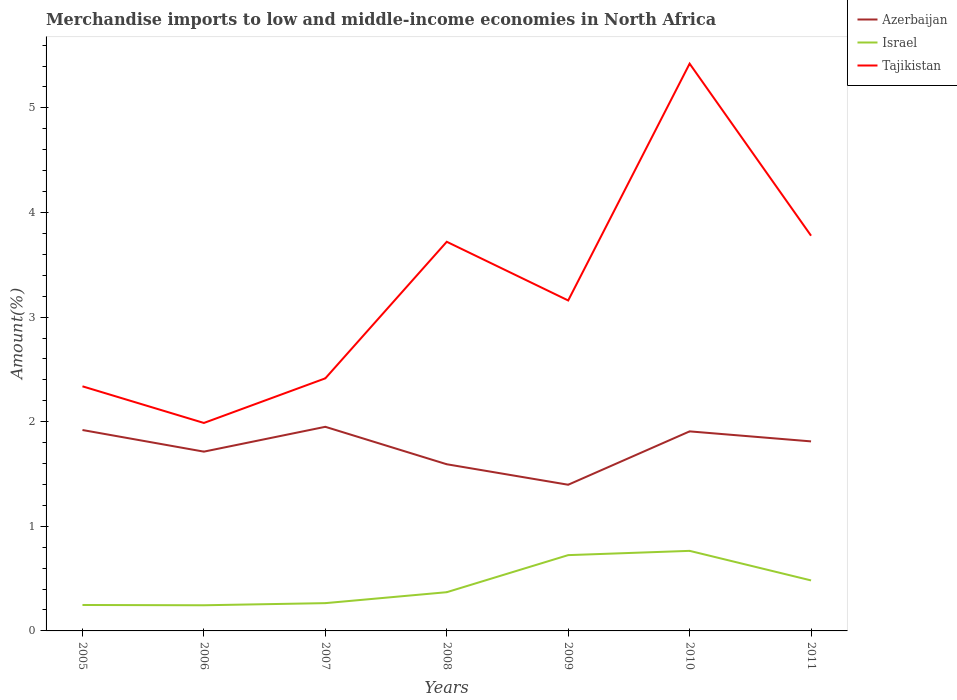Is the number of lines equal to the number of legend labels?
Your response must be concise. Yes. Across all years, what is the maximum percentage of amount earned from merchandise imports in Azerbaijan?
Your answer should be compact. 1.4. What is the total percentage of amount earned from merchandise imports in Tajikistan in the graph?
Offer a very short reply. -0.06. What is the difference between the highest and the second highest percentage of amount earned from merchandise imports in Israel?
Provide a succinct answer. 0.52. Is the percentage of amount earned from merchandise imports in Azerbaijan strictly greater than the percentage of amount earned from merchandise imports in Tajikistan over the years?
Your response must be concise. Yes. How many lines are there?
Give a very brief answer. 3. How are the legend labels stacked?
Keep it short and to the point. Vertical. What is the title of the graph?
Provide a succinct answer. Merchandise imports to low and middle-income economies in North Africa. What is the label or title of the X-axis?
Offer a very short reply. Years. What is the label or title of the Y-axis?
Ensure brevity in your answer.  Amount(%). What is the Amount(%) of Azerbaijan in 2005?
Your answer should be compact. 1.92. What is the Amount(%) of Israel in 2005?
Your response must be concise. 0.25. What is the Amount(%) in Tajikistan in 2005?
Ensure brevity in your answer.  2.34. What is the Amount(%) of Azerbaijan in 2006?
Keep it short and to the point. 1.71. What is the Amount(%) of Israel in 2006?
Provide a short and direct response. 0.25. What is the Amount(%) of Tajikistan in 2006?
Offer a very short reply. 1.99. What is the Amount(%) of Azerbaijan in 2007?
Your answer should be compact. 1.95. What is the Amount(%) in Israel in 2007?
Your answer should be compact. 0.27. What is the Amount(%) in Tajikistan in 2007?
Your answer should be very brief. 2.41. What is the Amount(%) of Azerbaijan in 2008?
Offer a terse response. 1.59. What is the Amount(%) of Israel in 2008?
Offer a very short reply. 0.37. What is the Amount(%) in Tajikistan in 2008?
Your response must be concise. 3.72. What is the Amount(%) in Azerbaijan in 2009?
Offer a very short reply. 1.4. What is the Amount(%) of Israel in 2009?
Provide a succinct answer. 0.72. What is the Amount(%) of Tajikistan in 2009?
Provide a short and direct response. 3.16. What is the Amount(%) of Azerbaijan in 2010?
Offer a very short reply. 1.91. What is the Amount(%) in Israel in 2010?
Your answer should be very brief. 0.77. What is the Amount(%) of Tajikistan in 2010?
Provide a short and direct response. 5.42. What is the Amount(%) in Azerbaijan in 2011?
Your answer should be compact. 1.81. What is the Amount(%) of Israel in 2011?
Your response must be concise. 0.48. What is the Amount(%) of Tajikistan in 2011?
Keep it short and to the point. 3.78. Across all years, what is the maximum Amount(%) in Azerbaijan?
Make the answer very short. 1.95. Across all years, what is the maximum Amount(%) of Israel?
Provide a succinct answer. 0.77. Across all years, what is the maximum Amount(%) of Tajikistan?
Your answer should be compact. 5.42. Across all years, what is the minimum Amount(%) of Azerbaijan?
Offer a terse response. 1.4. Across all years, what is the minimum Amount(%) of Israel?
Your answer should be compact. 0.25. Across all years, what is the minimum Amount(%) in Tajikistan?
Keep it short and to the point. 1.99. What is the total Amount(%) in Azerbaijan in the graph?
Offer a very short reply. 12.3. What is the total Amount(%) in Israel in the graph?
Your answer should be very brief. 3.1. What is the total Amount(%) of Tajikistan in the graph?
Make the answer very short. 22.82. What is the difference between the Amount(%) in Azerbaijan in 2005 and that in 2006?
Your answer should be very brief. 0.21. What is the difference between the Amount(%) in Israel in 2005 and that in 2006?
Ensure brevity in your answer.  0. What is the difference between the Amount(%) in Tajikistan in 2005 and that in 2006?
Make the answer very short. 0.35. What is the difference between the Amount(%) in Azerbaijan in 2005 and that in 2007?
Provide a succinct answer. -0.03. What is the difference between the Amount(%) of Israel in 2005 and that in 2007?
Ensure brevity in your answer.  -0.02. What is the difference between the Amount(%) of Tajikistan in 2005 and that in 2007?
Make the answer very short. -0.08. What is the difference between the Amount(%) in Azerbaijan in 2005 and that in 2008?
Keep it short and to the point. 0.33. What is the difference between the Amount(%) of Israel in 2005 and that in 2008?
Give a very brief answer. -0.12. What is the difference between the Amount(%) of Tajikistan in 2005 and that in 2008?
Offer a terse response. -1.38. What is the difference between the Amount(%) in Azerbaijan in 2005 and that in 2009?
Ensure brevity in your answer.  0.52. What is the difference between the Amount(%) of Israel in 2005 and that in 2009?
Make the answer very short. -0.48. What is the difference between the Amount(%) of Tajikistan in 2005 and that in 2009?
Provide a succinct answer. -0.82. What is the difference between the Amount(%) in Azerbaijan in 2005 and that in 2010?
Your response must be concise. 0.01. What is the difference between the Amount(%) in Israel in 2005 and that in 2010?
Your answer should be compact. -0.52. What is the difference between the Amount(%) in Tajikistan in 2005 and that in 2010?
Your response must be concise. -3.08. What is the difference between the Amount(%) of Azerbaijan in 2005 and that in 2011?
Provide a succinct answer. 0.11. What is the difference between the Amount(%) in Israel in 2005 and that in 2011?
Give a very brief answer. -0.23. What is the difference between the Amount(%) of Tajikistan in 2005 and that in 2011?
Offer a very short reply. -1.44. What is the difference between the Amount(%) of Azerbaijan in 2006 and that in 2007?
Ensure brevity in your answer.  -0.24. What is the difference between the Amount(%) of Israel in 2006 and that in 2007?
Make the answer very short. -0.02. What is the difference between the Amount(%) of Tajikistan in 2006 and that in 2007?
Offer a terse response. -0.43. What is the difference between the Amount(%) of Azerbaijan in 2006 and that in 2008?
Offer a very short reply. 0.12. What is the difference between the Amount(%) of Israel in 2006 and that in 2008?
Keep it short and to the point. -0.12. What is the difference between the Amount(%) in Tajikistan in 2006 and that in 2008?
Your response must be concise. -1.73. What is the difference between the Amount(%) of Azerbaijan in 2006 and that in 2009?
Provide a short and direct response. 0.32. What is the difference between the Amount(%) in Israel in 2006 and that in 2009?
Offer a very short reply. -0.48. What is the difference between the Amount(%) of Tajikistan in 2006 and that in 2009?
Offer a very short reply. -1.17. What is the difference between the Amount(%) of Azerbaijan in 2006 and that in 2010?
Your answer should be very brief. -0.19. What is the difference between the Amount(%) in Israel in 2006 and that in 2010?
Your answer should be compact. -0.52. What is the difference between the Amount(%) of Tajikistan in 2006 and that in 2010?
Provide a short and direct response. -3.43. What is the difference between the Amount(%) in Azerbaijan in 2006 and that in 2011?
Offer a terse response. -0.1. What is the difference between the Amount(%) of Israel in 2006 and that in 2011?
Provide a succinct answer. -0.24. What is the difference between the Amount(%) of Tajikistan in 2006 and that in 2011?
Keep it short and to the point. -1.79. What is the difference between the Amount(%) in Azerbaijan in 2007 and that in 2008?
Offer a very short reply. 0.36. What is the difference between the Amount(%) in Israel in 2007 and that in 2008?
Keep it short and to the point. -0.1. What is the difference between the Amount(%) in Tajikistan in 2007 and that in 2008?
Your response must be concise. -1.31. What is the difference between the Amount(%) of Azerbaijan in 2007 and that in 2009?
Keep it short and to the point. 0.55. What is the difference between the Amount(%) of Israel in 2007 and that in 2009?
Offer a terse response. -0.46. What is the difference between the Amount(%) in Tajikistan in 2007 and that in 2009?
Keep it short and to the point. -0.74. What is the difference between the Amount(%) in Azerbaijan in 2007 and that in 2010?
Offer a terse response. 0.04. What is the difference between the Amount(%) of Israel in 2007 and that in 2010?
Your answer should be compact. -0.5. What is the difference between the Amount(%) in Tajikistan in 2007 and that in 2010?
Keep it short and to the point. -3.01. What is the difference between the Amount(%) of Azerbaijan in 2007 and that in 2011?
Keep it short and to the point. 0.14. What is the difference between the Amount(%) in Israel in 2007 and that in 2011?
Offer a terse response. -0.22. What is the difference between the Amount(%) of Tajikistan in 2007 and that in 2011?
Your response must be concise. -1.36. What is the difference between the Amount(%) of Azerbaijan in 2008 and that in 2009?
Offer a very short reply. 0.2. What is the difference between the Amount(%) in Israel in 2008 and that in 2009?
Offer a very short reply. -0.35. What is the difference between the Amount(%) of Tajikistan in 2008 and that in 2009?
Provide a succinct answer. 0.56. What is the difference between the Amount(%) of Azerbaijan in 2008 and that in 2010?
Make the answer very short. -0.31. What is the difference between the Amount(%) of Israel in 2008 and that in 2010?
Give a very brief answer. -0.4. What is the difference between the Amount(%) in Tajikistan in 2008 and that in 2010?
Your answer should be very brief. -1.7. What is the difference between the Amount(%) of Azerbaijan in 2008 and that in 2011?
Give a very brief answer. -0.22. What is the difference between the Amount(%) in Israel in 2008 and that in 2011?
Provide a succinct answer. -0.11. What is the difference between the Amount(%) of Tajikistan in 2008 and that in 2011?
Offer a terse response. -0.06. What is the difference between the Amount(%) in Azerbaijan in 2009 and that in 2010?
Your answer should be compact. -0.51. What is the difference between the Amount(%) in Israel in 2009 and that in 2010?
Make the answer very short. -0.04. What is the difference between the Amount(%) of Tajikistan in 2009 and that in 2010?
Ensure brevity in your answer.  -2.26. What is the difference between the Amount(%) in Azerbaijan in 2009 and that in 2011?
Provide a short and direct response. -0.41. What is the difference between the Amount(%) of Israel in 2009 and that in 2011?
Make the answer very short. 0.24. What is the difference between the Amount(%) of Tajikistan in 2009 and that in 2011?
Your answer should be very brief. -0.62. What is the difference between the Amount(%) of Azerbaijan in 2010 and that in 2011?
Your response must be concise. 0.1. What is the difference between the Amount(%) in Israel in 2010 and that in 2011?
Provide a short and direct response. 0.28. What is the difference between the Amount(%) in Tajikistan in 2010 and that in 2011?
Make the answer very short. 1.64. What is the difference between the Amount(%) in Azerbaijan in 2005 and the Amount(%) in Israel in 2006?
Offer a terse response. 1.68. What is the difference between the Amount(%) of Azerbaijan in 2005 and the Amount(%) of Tajikistan in 2006?
Provide a succinct answer. -0.07. What is the difference between the Amount(%) in Israel in 2005 and the Amount(%) in Tajikistan in 2006?
Your answer should be compact. -1.74. What is the difference between the Amount(%) of Azerbaijan in 2005 and the Amount(%) of Israel in 2007?
Offer a very short reply. 1.66. What is the difference between the Amount(%) of Azerbaijan in 2005 and the Amount(%) of Tajikistan in 2007?
Your answer should be compact. -0.49. What is the difference between the Amount(%) in Israel in 2005 and the Amount(%) in Tajikistan in 2007?
Your answer should be very brief. -2.17. What is the difference between the Amount(%) of Azerbaijan in 2005 and the Amount(%) of Israel in 2008?
Your answer should be compact. 1.55. What is the difference between the Amount(%) of Azerbaijan in 2005 and the Amount(%) of Tajikistan in 2008?
Keep it short and to the point. -1.8. What is the difference between the Amount(%) of Israel in 2005 and the Amount(%) of Tajikistan in 2008?
Your answer should be very brief. -3.47. What is the difference between the Amount(%) of Azerbaijan in 2005 and the Amount(%) of Israel in 2009?
Your answer should be compact. 1.2. What is the difference between the Amount(%) of Azerbaijan in 2005 and the Amount(%) of Tajikistan in 2009?
Give a very brief answer. -1.24. What is the difference between the Amount(%) of Israel in 2005 and the Amount(%) of Tajikistan in 2009?
Offer a terse response. -2.91. What is the difference between the Amount(%) of Azerbaijan in 2005 and the Amount(%) of Israel in 2010?
Ensure brevity in your answer.  1.16. What is the difference between the Amount(%) in Azerbaijan in 2005 and the Amount(%) in Tajikistan in 2010?
Provide a short and direct response. -3.5. What is the difference between the Amount(%) in Israel in 2005 and the Amount(%) in Tajikistan in 2010?
Provide a succinct answer. -5.17. What is the difference between the Amount(%) in Azerbaijan in 2005 and the Amount(%) in Israel in 2011?
Ensure brevity in your answer.  1.44. What is the difference between the Amount(%) of Azerbaijan in 2005 and the Amount(%) of Tajikistan in 2011?
Provide a succinct answer. -1.86. What is the difference between the Amount(%) of Israel in 2005 and the Amount(%) of Tajikistan in 2011?
Your response must be concise. -3.53. What is the difference between the Amount(%) in Azerbaijan in 2006 and the Amount(%) in Israel in 2007?
Provide a succinct answer. 1.45. What is the difference between the Amount(%) in Azerbaijan in 2006 and the Amount(%) in Tajikistan in 2007?
Give a very brief answer. -0.7. What is the difference between the Amount(%) in Israel in 2006 and the Amount(%) in Tajikistan in 2007?
Your answer should be very brief. -2.17. What is the difference between the Amount(%) in Azerbaijan in 2006 and the Amount(%) in Israel in 2008?
Give a very brief answer. 1.34. What is the difference between the Amount(%) in Azerbaijan in 2006 and the Amount(%) in Tajikistan in 2008?
Give a very brief answer. -2.01. What is the difference between the Amount(%) in Israel in 2006 and the Amount(%) in Tajikistan in 2008?
Your answer should be very brief. -3.47. What is the difference between the Amount(%) in Azerbaijan in 2006 and the Amount(%) in Israel in 2009?
Provide a short and direct response. 0.99. What is the difference between the Amount(%) of Azerbaijan in 2006 and the Amount(%) of Tajikistan in 2009?
Keep it short and to the point. -1.45. What is the difference between the Amount(%) of Israel in 2006 and the Amount(%) of Tajikistan in 2009?
Provide a succinct answer. -2.91. What is the difference between the Amount(%) in Azerbaijan in 2006 and the Amount(%) in Israel in 2010?
Ensure brevity in your answer.  0.95. What is the difference between the Amount(%) in Azerbaijan in 2006 and the Amount(%) in Tajikistan in 2010?
Your answer should be compact. -3.71. What is the difference between the Amount(%) of Israel in 2006 and the Amount(%) of Tajikistan in 2010?
Your response must be concise. -5.18. What is the difference between the Amount(%) in Azerbaijan in 2006 and the Amount(%) in Israel in 2011?
Ensure brevity in your answer.  1.23. What is the difference between the Amount(%) in Azerbaijan in 2006 and the Amount(%) in Tajikistan in 2011?
Ensure brevity in your answer.  -2.06. What is the difference between the Amount(%) in Israel in 2006 and the Amount(%) in Tajikistan in 2011?
Provide a short and direct response. -3.53. What is the difference between the Amount(%) of Azerbaijan in 2007 and the Amount(%) of Israel in 2008?
Your response must be concise. 1.58. What is the difference between the Amount(%) in Azerbaijan in 2007 and the Amount(%) in Tajikistan in 2008?
Ensure brevity in your answer.  -1.77. What is the difference between the Amount(%) of Israel in 2007 and the Amount(%) of Tajikistan in 2008?
Your answer should be compact. -3.45. What is the difference between the Amount(%) in Azerbaijan in 2007 and the Amount(%) in Israel in 2009?
Your answer should be compact. 1.23. What is the difference between the Amount(%) of Azerbaijan in 2007 and the Amount(%) of Tajikistan in 2009?
Your answer should be compact. -1.21. What is the difference between the Amount(%) in Israel in 2007 and the Amount(%) in Tajikistan in 2009?
Ensure brevity in your answer.  -2.89. What is the difference between the Amount(%) of Azerbaijan in 2007 and the Amount(%) of Israel in 2010?
Offer a very short reply. 1.19. What is the difference between the Amount(%) of Azerbaijan in 2007 and the Amount(%) of Tajikistan in 2010?
Your answer should be very brief. -3.47. What is the difference between the Amount(%) of Israel in 2007 and the Amount(%) of Tajikistan in 2010?
Offer a very short reply. -5.16. What is the difference between the Amount(%) of Azerbaijan in 2007 and the Amount(%) of Israel in 2011?
Your answer should be compact. 1.47. What is the difference between the Amount(%) of Azerbaijan in 2007 and the Amount(%) of Tajikistan in 2011?
Keep it short and to the point. -1.83. What is the difference between the Amount(%) of Israel in 2007 and the Amount(%) of Tajikistan in 2011?
Give a very brief answer. -3.51. What is the difference between the Amount(%) in Azerbaijan in 2008 and the Amount(%) in Israel in 2009?
Keep it short and to the point. 0.87. What is the difference between the Amount(%) in Azerbaijan in 2008 and the Amount(%) in Tajikistan in 2009?
Provide a short and direct response. -1.57. What is the difference between the Amount(%) in Israel in 2008 and the Amount(%) in Tajikistan in 2009?
Keep it short and to the point. -2.79. What is the difference between the Amount(%) in Azerbaijan in 2008 and the Amount(%) in Israel in 2010?
Your answer should be very brief. 0.83. What is the difference between the Amount(%) in Azerbaijan in 2008 and the Amount(%) in Tajikistan in 2010?
Provide a short and direct response. -3.83. What is the difference between the Amount(%) in Israel in 2008 and the Amount(%) in Tajikistan in 2010?
Give a very brief answer. -5.05. What is the difference between the Amount(%) of Azerbaijan in 2008 and the Amount(%) of Israel in 2011?
Offer a terse response. 1.11. What is the difference between the Amount(%) in Azerbaijan in 2008 and the Amount(%) in Tajikistan in 2011?
Make the answer very short. -2.18. What is the difference between the Amount(%) of Israel in 2008 and the Amount(%) of Tajikistan in 2011?
Provide a short and direct response. -3.41. What is the difference between the Amount(%) of Azerbaijan in 2009 and the Amount(%) of Israel in 2010?
Offer a terse response. 0.63. What is the difference between the Amount(%) of Azerbaijan in 2009 and the Amount(%) of Tajikistan in 2010?
Provide a short and direct response. -4.03. What is the difference between the Amount(%) of Israel in 2009 and the Amount(%) of Tajikistan in 2010?
Give a very brief answer. -4.7. What is the difference between the Amount(%) of Azerbaijan in 2009 and the Amount(%) of Israel in 2011?
Provide a succinct answer. 0.91. What is the difference between the Amount(%) of Azerbaijan in 2009 and the Amount(%) of Tajikistan in 2011?
Make the answer very short. -2.38. What is the difference between the Amount(%) in Israel in 2009 and the Amount(%) in Tajikistan in 2011?
Make the answer very short. -3.05. What is the difference between the Amount(%) in Azerbaijan in 2010 and the Amount(%) in Israel in 2011?
Offer a terse response. 1.42. What is the difference between the Amount(%) in Azerbaijan in 2010 and the Amount(%) in Tajikistan in 2011?
Your answer should be very brief. -1.87. What is the difference between the Amount(%) of Israel in 2010 and the Amount(%) of Tajikistan in 2011?
Provide a succinct answer. -3.01. What is the average Amount(%) in Azerbaijan per year?
Give a very brief answer. 1.76. What is the average Amount(%) of Israel per year?
Ensure brevity in your answer.  0.44. What is the average Amount(%) in Tajikistan per year?
Your answer should be very brief. 3.26. In the year 2005, what is the difference between the Amount(%) of Azerbaijan and Amount(%) of Israel?
Make the answer very short. 1.67. In the year 2005, what is the difference between the Amount(%) in Azerbaijan and Amount(%) in Tajikistan?
Ensure brevity in your answer.  -0.42. In the year 2005, what is the difference between the Amount(%) in Israel and Amount(%) in Tajikistan?
Make the answer very short. -2.09. In the year 2006, what is the difference between the Amount(%) of Azerbaijan and Amount(%) of Israel?
Ensure brevity in your answer.  1.47. In the year 2006, what is the difference between the Amount(%) of Azerbaijan and Amount(%) of Tajikistan?
Offer a very short reply. -0.27. In the year 2006, what is the difference between the Amount(%) in Israel and Amount(%) in Tajikistan?
Provide a succinct answer. -1.74. In the year 2007, what is the difference between the Amount(%) in Azerbaijan and Amount(%) in Israel?
Your response must be concise. 1.69. In the year 2007, what is the difference between the Amount(%) of Azerbaijan and Amount(%) of Tajikistan?
Your response must be concise. -0.46. In the year 2007, what is the difference between the Amount(%) in Israel and Amount(%) in Tajikistan?
Ensure brevity in your answer.  -2.15. In the year 2008, what is the difference between the Amount(%) in Azerbaijan and Amount(%) in Israel?
Ensure brevity in your answer.  1.22. In the year 2008, what is the difference between the Amount(%) in Azerbaijan and Amount(%) in Tajikistan?
Provide a succinct answer. -2.13. In the year 2008, what is the difference between the Amount(%) of Israel and Amount(%) of Tajikistan?
Your answer should be very brief. -3.35. In the year 2009, what is the difference between the Amount(%) of Azerbaijan and Amount(%) of Israel?
Your answer should be compact. 0.67. In the year 2009, what is the difference between the Amount(%) of Azerbaijan and Amount(%) of Tajikistan?
Give a very brief answer. -1.76. In the year 2009, what is the difference between the Amount(%) of Israel and Amount(%) of Tajikistan?
Your answer should be very brief. -2.43. In the year 2010, what is the difference between the Amount(%) of Azerbaijan and Amount(%) of Israel?
Keep it short and to the point. 1.14. In the year 2010, what is the difference between the Amount(%) of Azerbaijan and Amount(%) of Tajikistan?
Offer a very short reply. -3.52. In the year 2010, what is the difference between the Amount(%) of Israel and Amount(%) of Tajikistan?
Ensure brevity in your answer.  -4.66. In the year 2011, what is the difference between the Amount(%) of Azerbaijan and Amount(%) of Israel?
Make the answer very short. 1.33. In the year 2011, what is the difference between the Amount(%) in Azerbaijan and Amount(%) in Tajikistan?
Make the answer very short. -1.97. In the year 2011, what is the difference between the Amount(%) in Israel and Amount(%) in Tajikistan?
Make the answer very short. -3.3. What is the ratio of the Amount(%) of Azerbaijan in 2005 to that in 2006?
Make the answer very short. 1.12. What is the ratio of the Amount(%) of Israel in 2005 to that in 2006?
Your answer should be very brief. 1.01. What is the ratio of the Amount(%) of Tajikistan in 2005 to that in 2006?
Provide a succinct answer. 1.18. What is the ratio of the Amount(%) of Azerbaijan in 2005 to that in 2007?
Your response must be concise. 0.98. What is the ratio of the Amount(%) in Israel in 2005 to that in 2007?
Provide a short and direct response. 0.93. What is the ratio of the Amount(%) in Tajikistan in 2005 to that in 2007?
Your answer should be very brief. 0.97. What is the ratio of the Amount(%) of Azerbaijan in 2005 to that in 2008?
Your answer should be compact. 1.21. What is the ratio of the Amount(%) of Israel in 2005 to that in 2008?
Give a very brief answer. 0.67. What is the ratio of the Amount(%) in Tajikistan in 2005 to that in 2008?
Keep it short and to the point. 0.63. What is the ratio of the Amount(%) in Azerbaijan in 2005 to that in 2009?
Your answer should be compact. 1.37. What is the ratio of the Amount(%) in Israel in 2005 to that in 2009?
Ensure brevity in your answer.  0.34. What is the ratio of the Amount(%) in Tajikistan in 2005 to that in 2009?
Offer a terse response. 0.74. What is the ratio of the Amount(%) in Azerbaijan in 2005 to that in 2010?
Your answer should be compact. 1.01. What is the ratio of the Amount(%) of Israel in 2005 to that in 2010?
Your response must be concise. 0.32. What is the ratio of the Amount(%) in Tajikistan in 2005 to that in 2010?
Ensure brevity in your answer.  0.43. What is the ratio of the Amount(%) of Azerbaijan in 2005 to that in 2011?
Make the answer very short. 1.06. What is the ratio of the Amount(%) of Israel in 2005 to that in 2011?
Your answer should be compact. 0.51. What is the ratio of the Amount(%) in Tajikistan in 2005 to that in 2011?
Provide a short and direct response. 0.62. What is the ratio of the Amount(%) in Azerbaijan in 2006 to that in 2007?
Keep it short and to the point. 0.88. What is the ratio of the Amount(%) of Israel in 2006 to that in 2007?
Offer a terse response. 0.92. What is the ratio of the Amount(%) in Tajikistan in 2006 to that in 2007?
Keep it short and to the point. 0.82. What is the ratio of the Amount(%) of Azerbaijan in 2006 to that in 2008?
Your answer should be compact. 1.08. What is the ratio of the Amount(%) of Israel in 2006 to that in 2008?
Your answer should be very brief. 0.66. What is the ratio of the Amount(%) in Tajikistan in 2006 to that in 2008?
Keep it short and to the point. 0.53. What is the ratio of the Amount(%) in Azerbaijan in 2006 to that in 2009?
Offer a very short reply. 1.23. What is the ratio of the Amount(%) in Israel in 2006 to that in 2009?
Offer a very short reply. 0.34. What is the ratio of the Amount(%) of Tajikistan in 2006 to that in 2009?
Provide a succinct answer. 0.63. What is the ratio of the Amount(%) of Azerbaijan in 2006 to that in 2010?
Your response must be concise. 0.9. What is the ratio of the Amount(%) in Israel in 2006 to that in 2010?
Make the answer very short. 0.32. What is the ratio of the Amount(%) in Tajikistan in 2006 to that in 2010?
Make the answer very short. 0.37. What is the ratio of the Amount(%) of Azerbaijan in 2006 to that in 2011?
Give a very brief answer. 0.95. What is the ratio of the Amount(%) in Israel in 2006 to that in 2011?
Offer a terse response. 0.51. What is the ratio of the Amount(%) of Tajikistan in 2006 to that in 2011?
Give a very brief answer. 0.53. What is the ratio of the Amount(%) in Azerbaijan in 2007 to that in 2008?
Your answer should be compact. 1.22. What is the ratio of the Amount(%) of Israel in 2007 to that in 2008?
Ensure brevity in your answer.  0.72. What is the ratio of the Amount(%) in Tajikistan in 2007 to that in 2008?
Give a very brief answer. 0.65. What is the ratio of the Amount(%) of Azerbaijan in 2007 to that in 2009?
Offer a very short reply. 1.4. What is the ratio of the Amount(%) of Israel in 2007 to that in 2009?
Provide a short and direct response. 0.37. What is the ratio of the Amount(%) of Tajikistan in 2007 to that in 2009?
Your answer should be compact. 0.76. What is the ratio of the Amount(%) of Azerbaijan in 2007 to that in 2010?
Give a very brief answer. 1.02. What is the ratio of the Amount(%) of Israel in 2007 to that in 2010?
Your answer should be very brief. 0.35. What is the ratio of the Amount(%) in Tajikistan in 2007 to that in 2010?
Give a very brief answer. 0.45. What is the ratio of the Amount(%) in Israel in 2007 to that in 2011?
Your answer should be compact. 0.55. What is the ratio of the Amount(%) of Tajikistan in 2007 to that in 2011?
Ensure brevity in your answer.  0.64. What is the ratio of the Amount(%) in Azerbaijan in 2008 to that in 2009?
Give a very brief answer. 1.14. What is the ratio of the Amount(%) in Israel in 2008 to that in 2009?
Provide a short and direct response. 0.51. What is the ratio of the Amount(%) of Tajikistan in 2008 to that in 2009?
Your response must be concise. 1.18. What is the ratio of the Amount(%) of Azerbaijan in 2008 to that in 2010?
Your answer should be compact. 0.84. What is the ratio of the Amount(%) of Israel in 2008 to that in 2010?
Your answer should be compact. 0.48. What is the ratio of the Amount(%) in Tajikistan in 2008 to that in 2010?
Your answer should be compact. 0.69. What is the ratio of the Amount(%) of Azerbaijan in 2008 to that in 2011?
Your answer should be very brief. 0.88. What is the ratio of the Amount(%) of Israel in 2008 to that in 2011?
Your answer should be compact. 0.77. What is the ratio of the Amount(%) in Tajikistan in 2008 to that in 2011?
Ensure brevity in your answer.  0.98. What is the ratio of the Amount(%) of Azerbaijan in 2009 to that in 2010?
Offer a terse response. 0.73. What is the ratio of the Amount(%) in Israel in 2009 to that in 2010?
Your response must be concise. 0.95. What is the ratio of the Amount(%) in Tajikistan in 2009 to that in 2010?
Make the answer very short. 0.58. What is the ratio of the Amount(%) of Azerbaijan in 2009 to that in 2011?
Your answer should be compact. 0.77. What is the ratio of the Amount(%) of Israel in 2009 to that in 2011?
Ensure brevity in your answer.  1.5. What is the ratio of the Amount(%) in Tajikistan in 2009 to that in 2011?
Make the answer very short. 0.84. What is the ratio of the Amount(%) of Azerbaijan in 2010 to that in 2011?
Give a very brief answer. 1.05. What is the ratio of the Amount(%) in Israel in 2010 to that in 2011?
Give a very brief answer. 1.59. What is the ratio of the Amount(%) of Tajikistan in 2010 to that in 2011?
Your answer should be very brief. 1.44. What is the difference between the highest and the second highest Amount(%) of Azerbaijan?
Your response must be concise. 0.03. What is the difference between the highest and the second highest Amount(%) of Israel?
Offer a terse response. 0.04. What is the difference between the highest and the second highest Amount(%) of Tajikistan?
Offer a terse response. 1.64. What is the difference between the highest and the lowest Amount(%) in Azerbaijan?
Make the answer very short. 0.55. What is the difference between the highest and the lowest Amount(%) in Israel?
Make the answer very short. 0.52. What is the difference between the highest and the lowest Amount(%) in Tajikistan?
Keep it short and to the point. 3.43. 